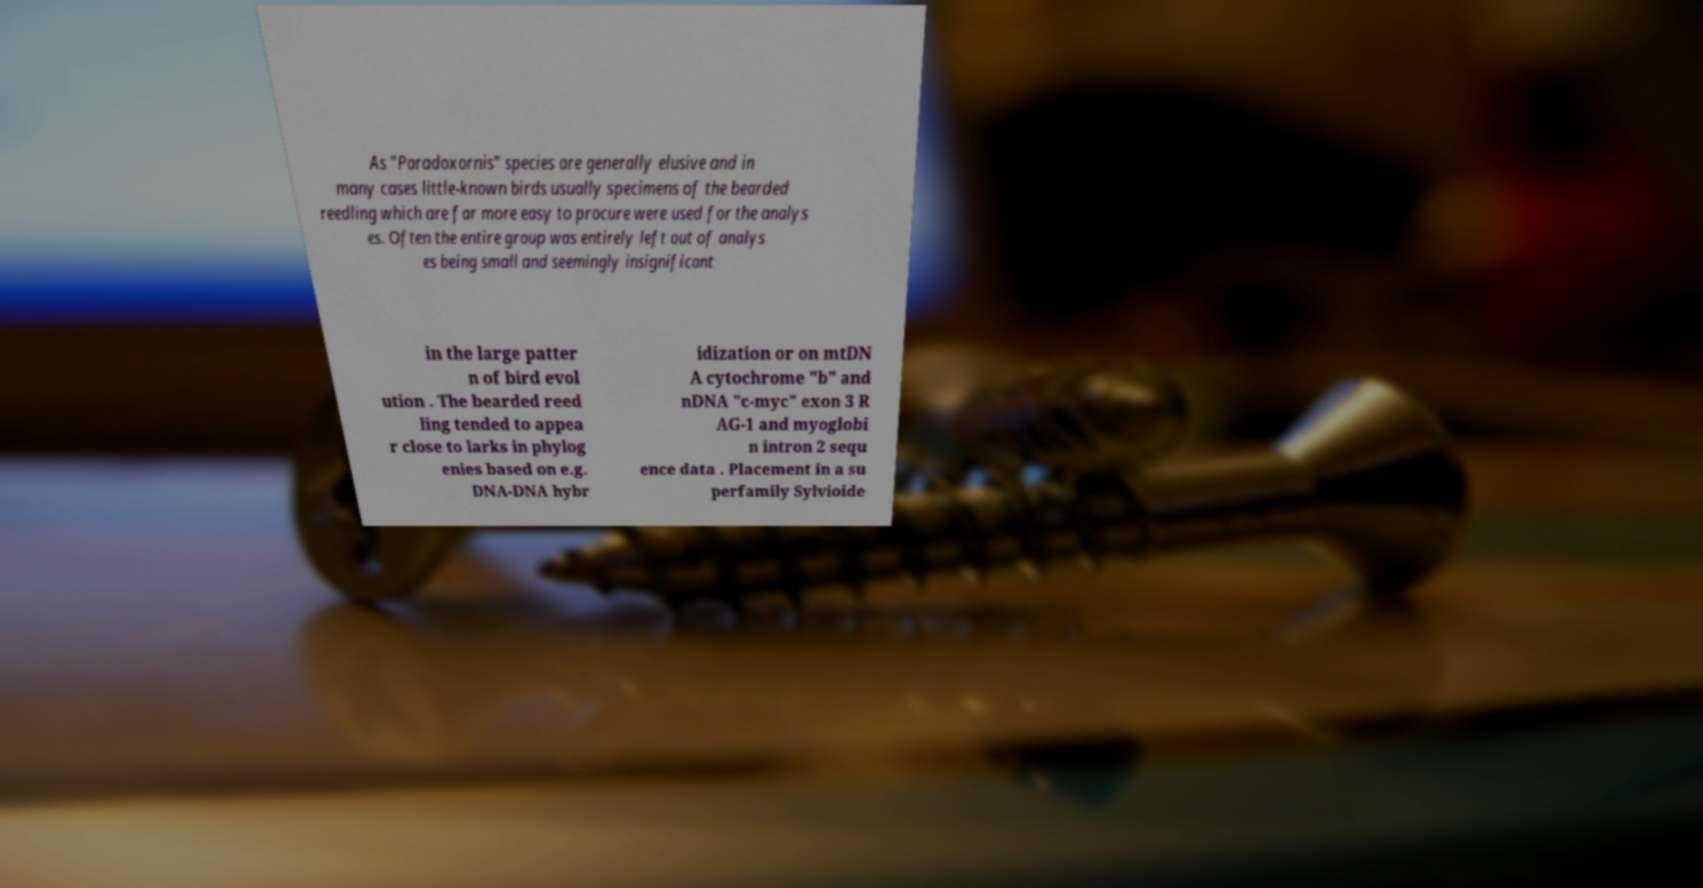I need the written content from this picture converted into text. Can you do that? As "Paradoxornis" species are generally elusive and in many cases little-known birds usually specimens of the bearded reedling which are far more easy to procure were used for the analys es. Often the entire group was entirely left out of analys es being small and seemingly insignificant in the large patter n of bird evol ution . The bearded reed ling tended to appea r close to larks in phylog enies based on e.g. DNA-DNA hybr idization or on mtDN A cytochrome "b" and nDNA "c-myc" exon 3 R AG-1 and myoglobi n intron 2 sequ ence data . Placement in a su perfamily Sylvioide 